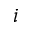<formula> <loc_0><loc_0><loc_500><loc_500>i</formula> 